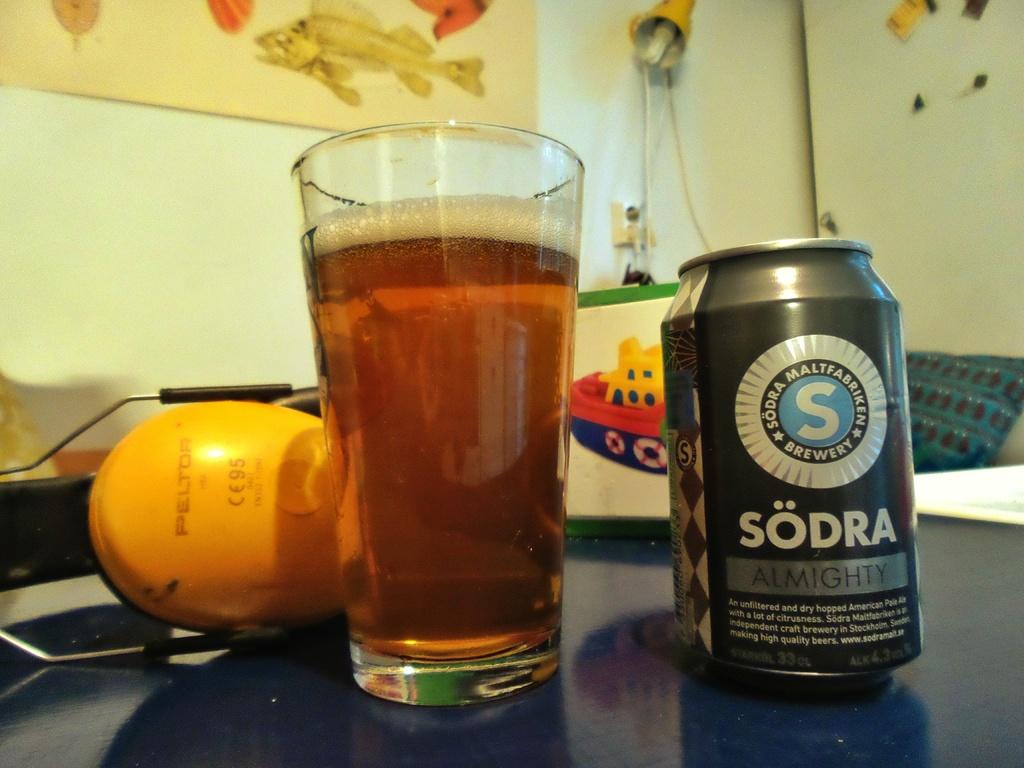What brewery produced this beer?
Offer a terse response. Sodra. 